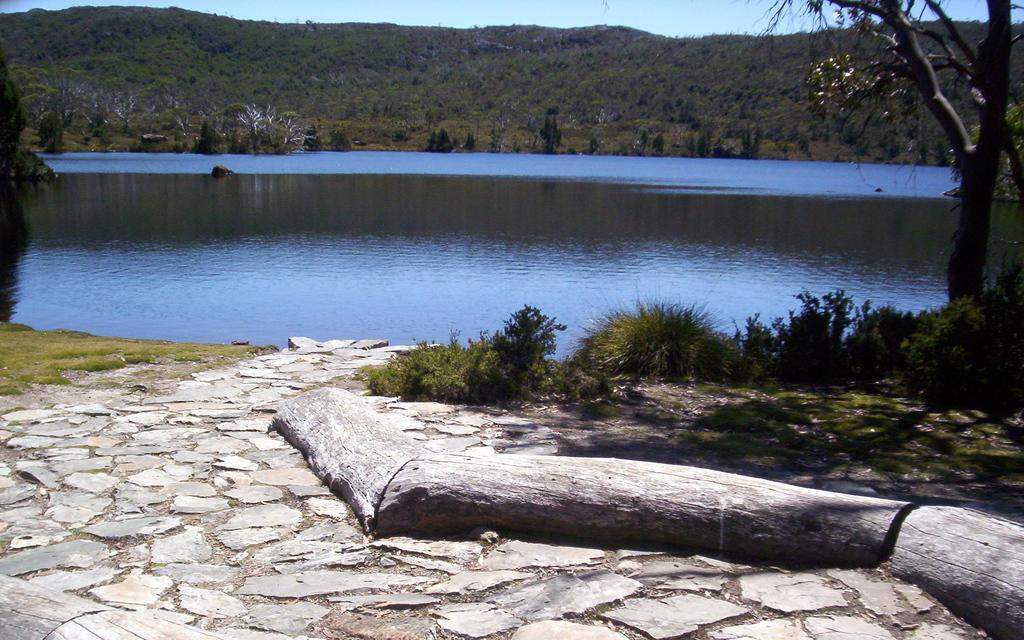What type of vegetation can be seen in the image? There are trees in the image. What type of ground cover is present in the image? There is grass in the image. What natural feature can be seen in the image? There is water in the image. What type of landscape feature is visible in the image? There are mountains in the image. What color is the sky in the image? The sky is blue in color. What type of rhythm can be heard coming from the trees in the image? There is no sound or rhythm present in the image; it is a still image of trees, grass, water, mountains, and a blue sky. 